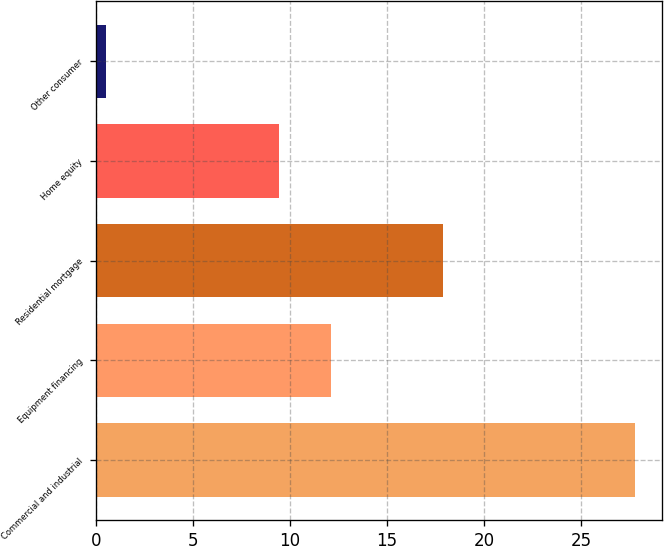Convert chart. <chart><loc_0><loc_0><loc_500><loc_500><bar_chart><fcel>Commercial and industrial<fcel>Equipment financing<fcel>Residential mortgage<fcel>Home equity<fcel>Other consumer<nl><fcel>27.8<fcel>12.13<fcel>17.9<fcel>9.4<fcel>0.5<nl></chart> 